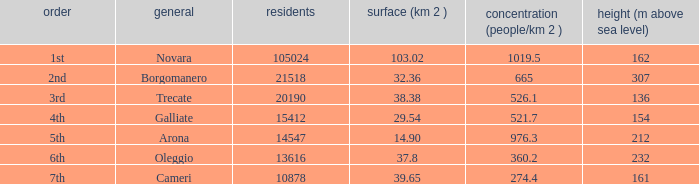What is the minimum altitude (mslm) in all the commons? 136.0. 